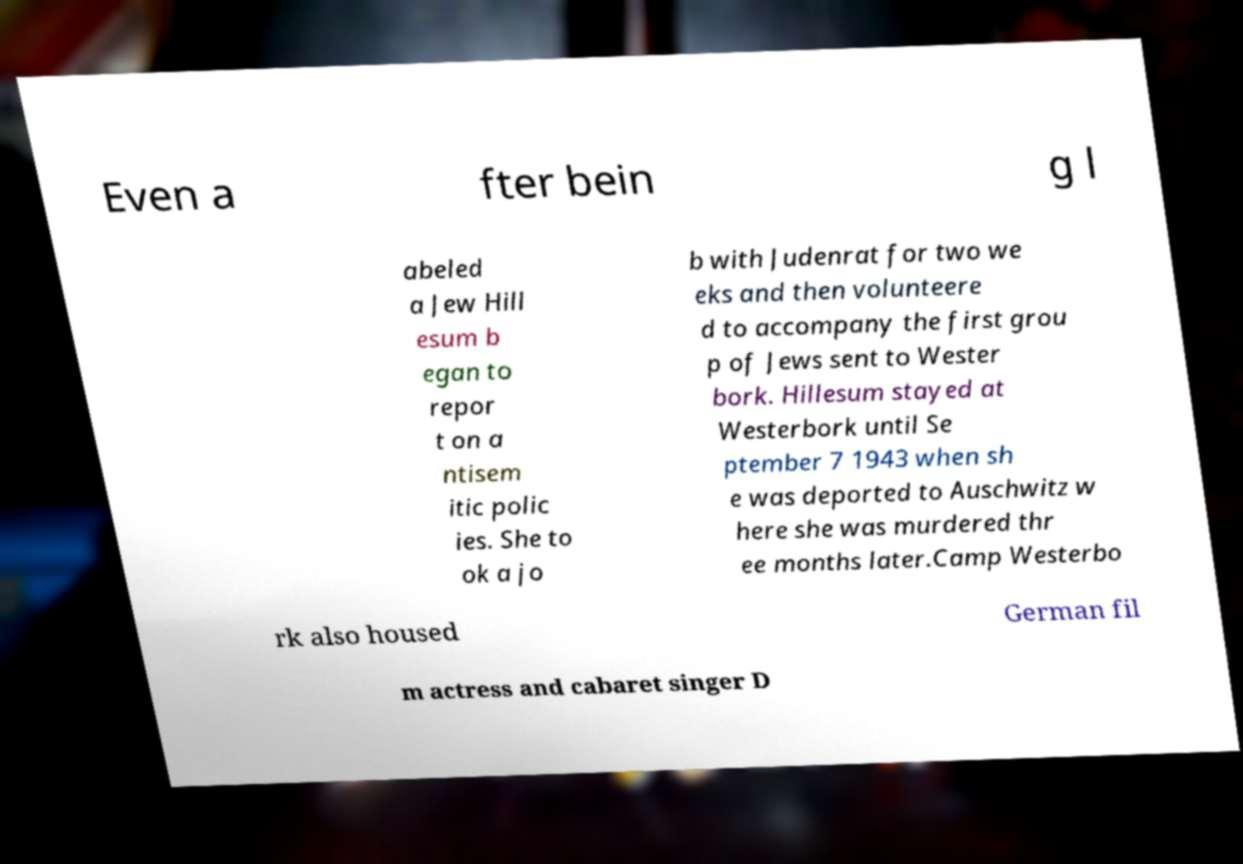For documentation purposes, I need the text within this image transcribed. Could you provide that? Even a fter bein g l abeled a Jew Hill esum b egan to repor t on a ntisem itic polic ies. She to ok a jo b with Judenrat for two we eks and then volunteere d to accompany the first grou p of Jews sent to Wester bork. Hillesum stayed at Westerbork until Se ptember 7 1943 when sh e was deported to Auschwitz w here she was murdered thr ee months later.Camp Westerbo rk also housed German fil m actress and cabaret singer D 